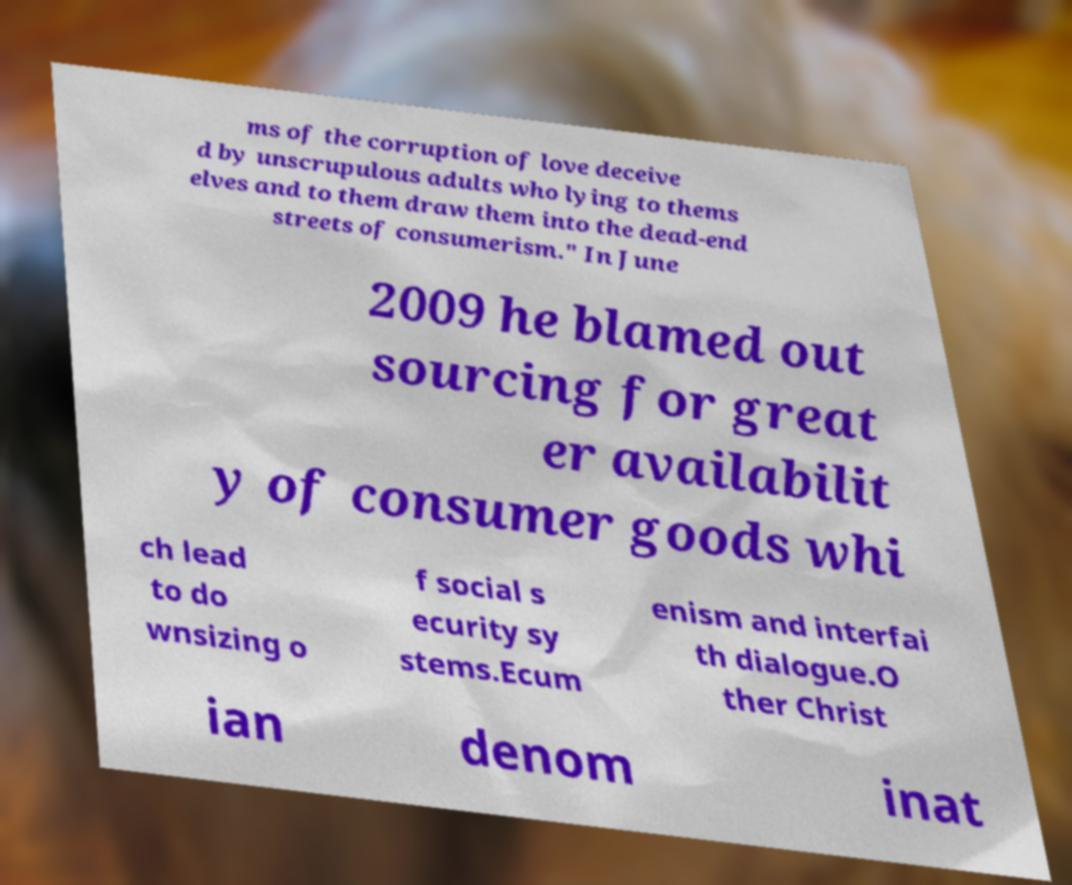Please read and relay the text visible in this image. What does it say? ms of the corruption of love deceive d by unscrupulous adults who lying to thems elves and to them draw them into the dead-end streets of consumerism." In June 2009 he blamed out sourcing for great er availabilit y of consumer goods whi ch lead to do wnsizing o f social s ecurity sy stems.Ecum enism and interfai th dialogue.O ther Christ ian denom inat 